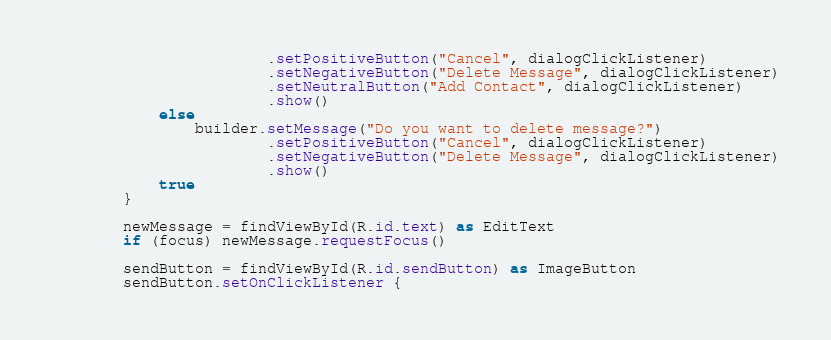Convert code to text. <code><loc_0><loc_0><loc_500><loc_500><_Kotlin_>                        .setPositiveButton("Cancel", dialogClickListener)
                        .setNegativeButton("Delete Message", dialogClickListener)
                        .setNeutralButton("Add Contact", dialogClickListener)
                        .show()
            else
                builder.setMessage("Do you want to delete message?")
                        .setPositiveButton("Cancel", dialogClickListener)
                        .setNegativeButton("Delete Message", dialogClickListener)
                        .show()
            true
        }

        newMessage = findViewById(R.id.text) as EditText
        if (focus) newMessage.requestFocus()

        sendButton = findViewById(R.id.sendButton) as ImageButton
        sendButton.setOnClickListener {</code> 